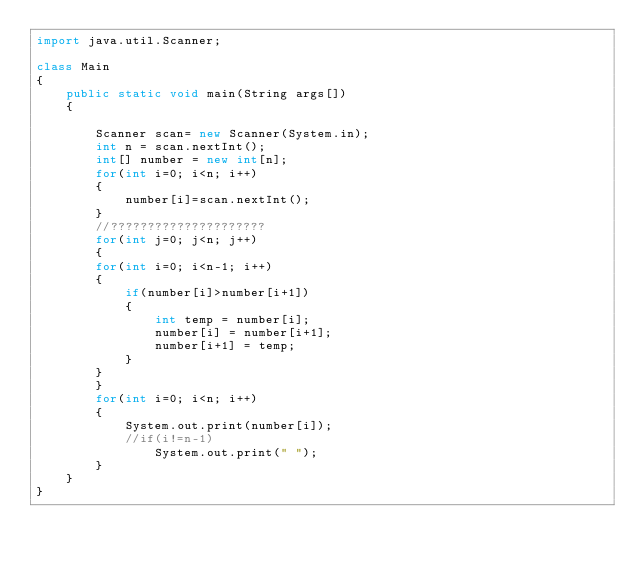<code> <loc_0><loc_0><loc_500><loc_500><_Java_>import java.util.Scanner;

class Main
{
	public static void main(String args[])
	{

		Scanner scan= new Scanner(System.in);
		int n = scan.nextInt();
		int[] number = new int[n];
		for(int i=0; i<n; i++)
		{
			number[i]=scan.nextInt();
		}
		//?????????????????????
		for(int j=0; j<n; j++)
		{
		for(int i=0; i<n-1; i++)
		{
			if(number[i]>number[i+1])
			{
				int temp = number[i];
				number[i] = number[i+1];
				number[i+1] = temp;
			}
		}
		}
		for(int i=0; i<n; i++)
		{
			System.out.print(number[i]);
			//if(i!=n-1)
				System.out.print(" ");
		}
	}
}</code> 